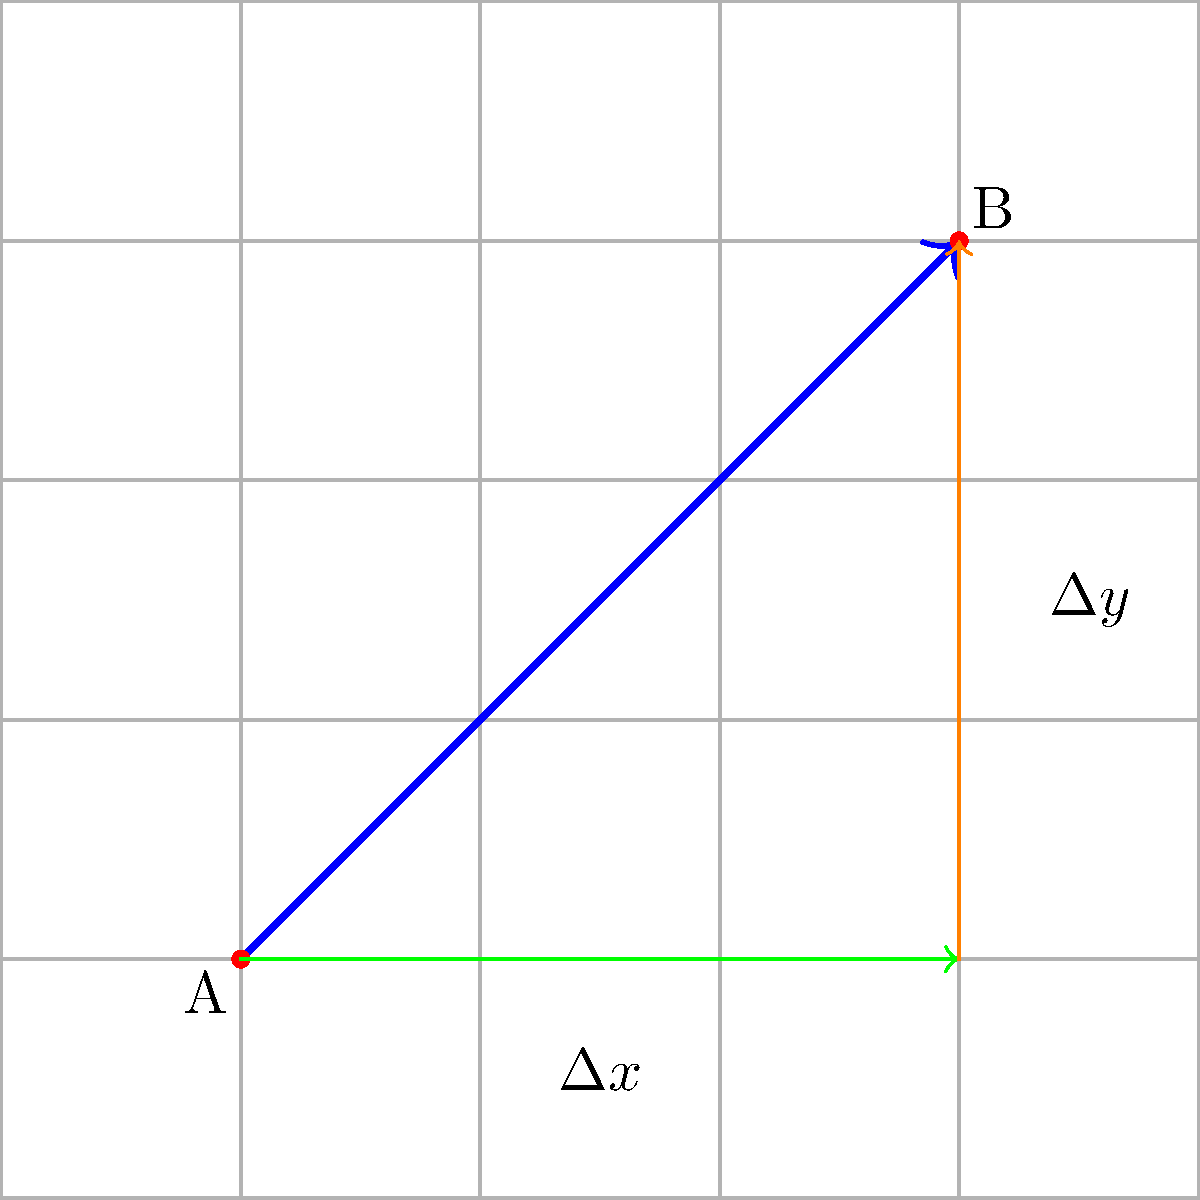In a grid-based board game, a token moves from point A to point B as shown in the diagram. The movement vector $\vec{v}$ can be decomposed into horizontal and vertical components. If each grid square represents 1 unit, what are the magnitudes of the horizontal ($\Delta x$) and vertical ($\Delta y$) components of the movement vector? To find the components of the movement vector, we need to analyze the change in x and y coordinates from point A to point B:

1. Identify the starting point A: (1, 1)
2. Identify the ending point B: (4, 4)
3. Calculate $\Delta x$:
   $\Delta x = x_B - x_A = 4 - 1 = 3$ units
4. Calculate $\Delta y$:
   $\Delta y = y_B - y_A = 4 - 1 = 3$ units

The horizontal component ($\Delta x$) represents the movement along the x-axis, which is 3 units to the right.
The vertical component ($\Delta y$) represents the movement along the y-axis, which is 3 units upward.

Therefore, the magnitudes of the horizontal and vertical components are both 3 units.
Answer: $\Delta x = 3, \Delta y = 3$ 